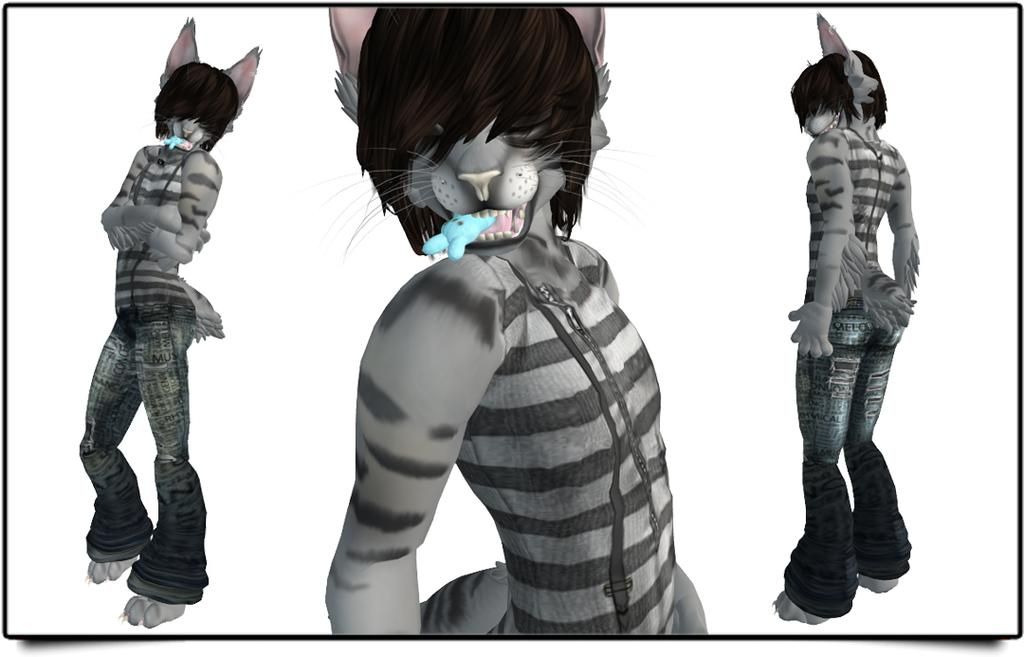What is the main subject of the image? The main subject of the image is an animation of an animal. How does the animal appear to move in the image? The animal is shown in different positions, which suggests movement. What is the color of the background in the image? The background in the image is white. Who is the famous actor that appears in the image? There is no actor present in the image; it features an animated animal. What historical event is depicted in the image? There is no historical event depicted in the image; it is an animation of an animal. 